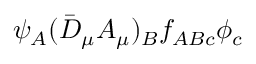Convert formula to latex. <formula><loc_0><loc_0><loc_500><loc_500>\psi _ { A } ( \bar { D } _ { \mu } A _ { \mu } ) _ { B } f _ { A B c } \phi _ { c }</formula> 